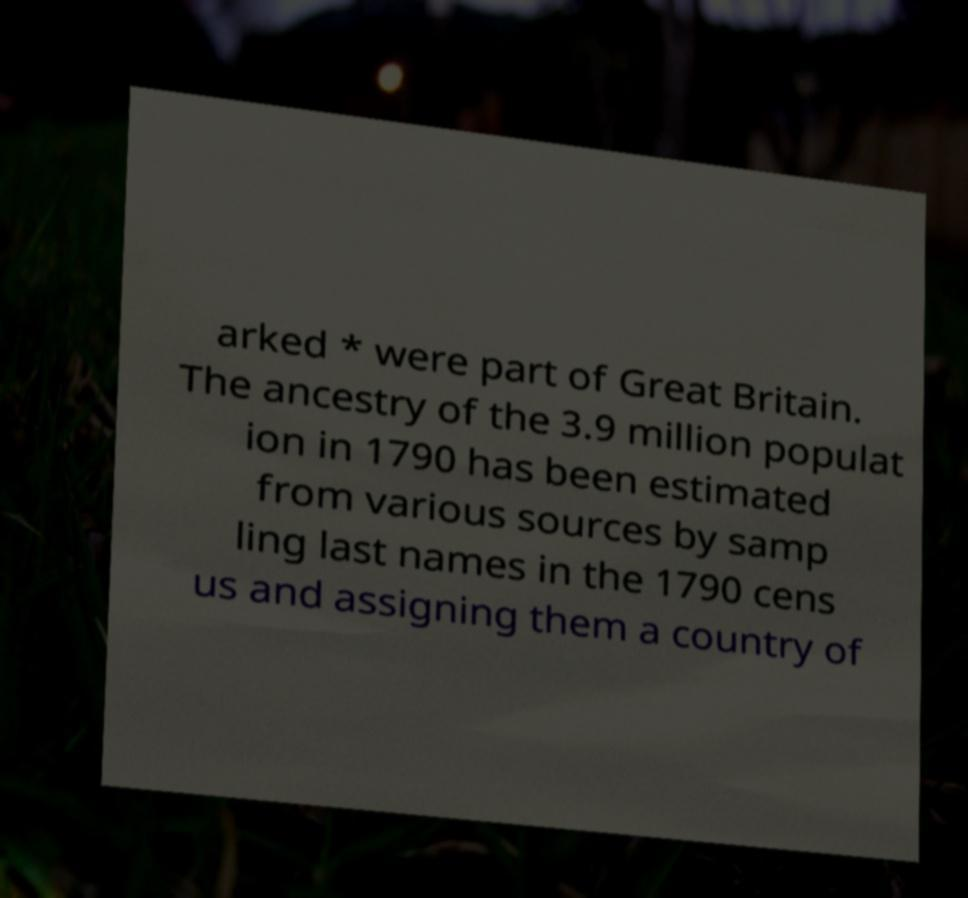There's text embedded in this image that I need extracted. Can you transcribe it verbatim? arked * were part of Great Britain. The ancestry of the 3.9 million populat ion in 1790 has been estimated from various sources by samp ling last names in the 1790 cens us and assigning them a country of 